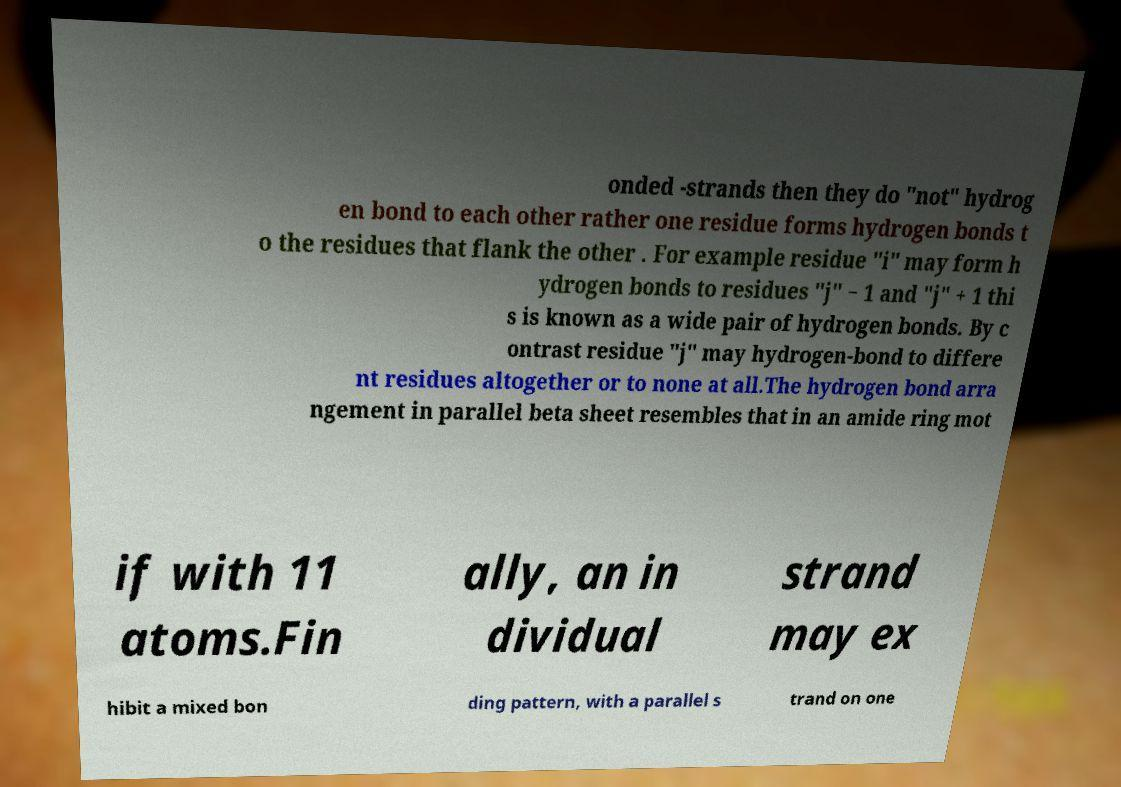Please identify and transcribe the text found in this image. onded -strands then they do "not" hydrog en bond to each other rather one residue forms hydrogen bonds t o the residues that flank the other . For example residue "i" may form h ydrogen bonds to residues "j" − 1 and "j" + 1 thi s is known as a wide pair of hydrogen bonds. By c ontrast residue "j" may hydrogen-bond to differe nt residues altogether or to none at all.The hydrogen bond arra ngement in parallel beta sheet resembles that in an amide ring mot if with 11 atoms.Fin ally, an in dividual strand may ex hibit a mixed bon ding pattern, with a parallel s trand on one 